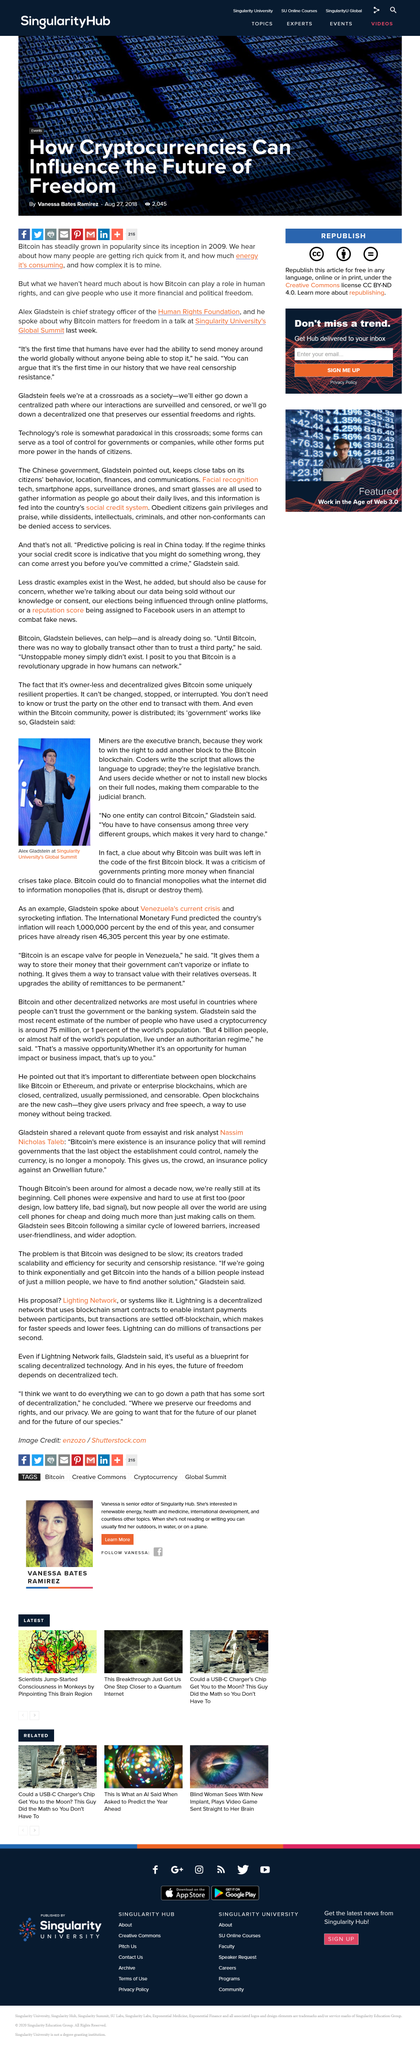Give some essential details in this illustration. Miners are the executive branch of the United States government, while the president is the ceremonial head. Alex Gladstein is featured in the photo, as stated. Gladstein was located in the photo at Singularity University's Global Summit. 